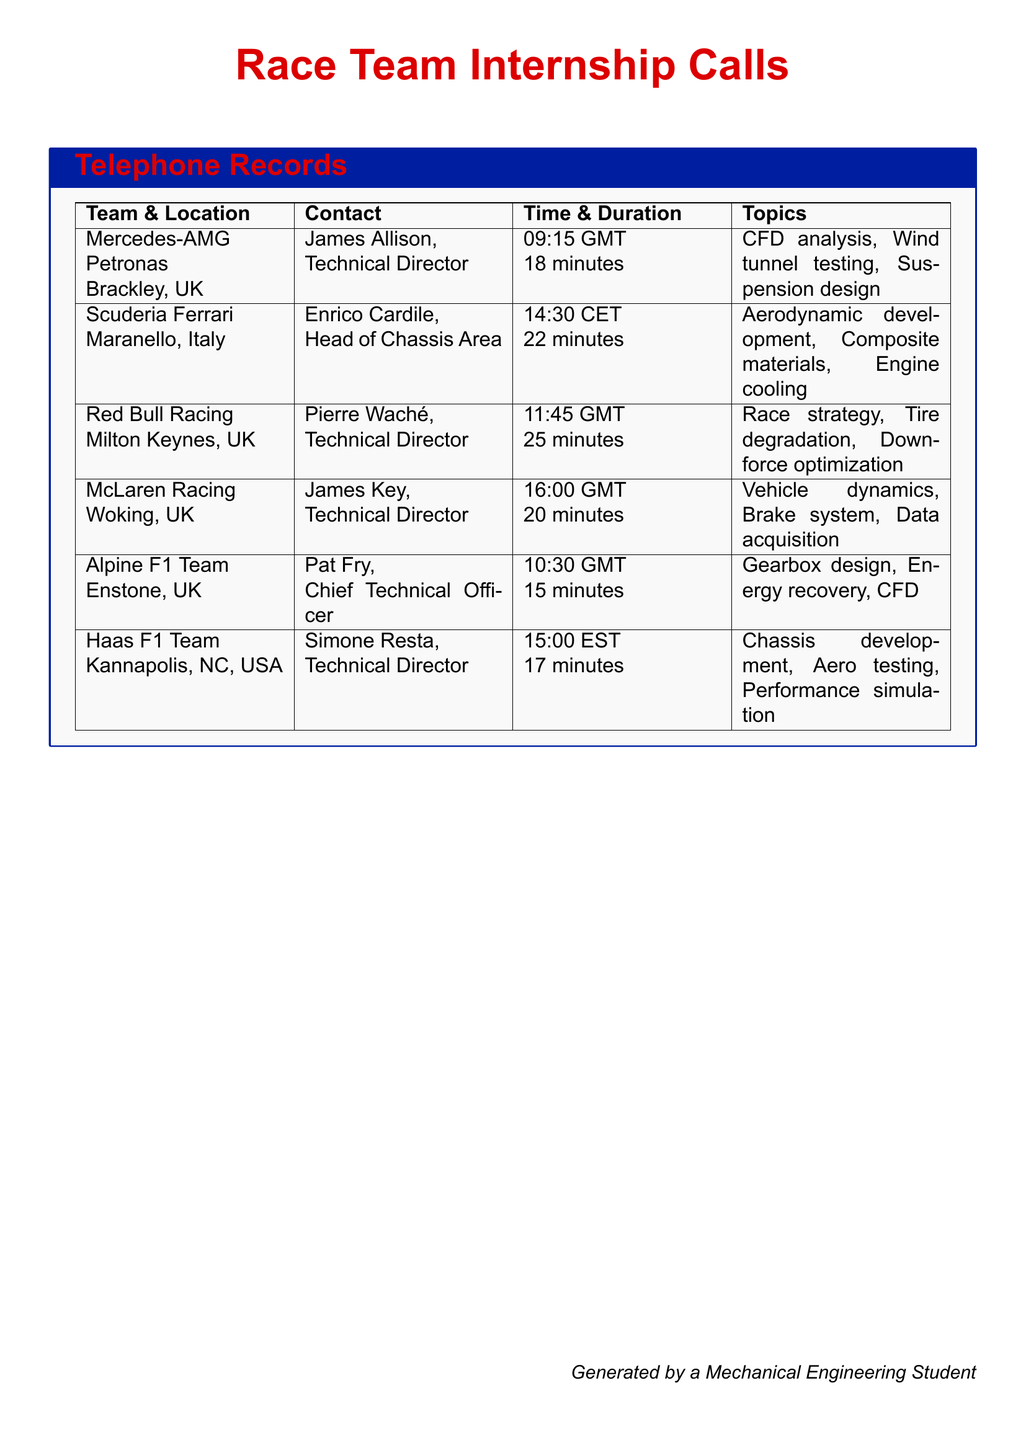What is the name of the Technical Director at Mercedes-AMG Petronas? The Technical Director at Mercedes-AMG Petronas is James Allison.
Answer: James Allison What is the duration of the call with Scuderia Ferrari? The call with Scuderia Ferrari lasted for 22 minutes.
Answer: 22 minutes Which team is located in Milton Keynes, UK? The team located in Milton Keynes, UK is Red Bull Racing.
Answer: Red Bull Racing What topics were discussed during the call with Alpine F1 Team? The topics discussed included gearbox design, energy recovery, and CFD.
Answer: Gearbox design, Energy recovery, CFD How many minutes did the call with Haas F1 Team last? The call with Haas F1 Team lasted for 17 minutes.
Answer: 17 minutes Which team's contact person is Enrico Cardile? Enrico Cardile is the contact person for Scuderia Ferrari.
Answer: Scuderia Ferrari What time zone was used for the call with McLaren Racing? The call with McLaren Racing was in GMT.
Answer: GMT What are the topics discussed during the call with Red Bull Racing? The topics discussed included race strategy, tire degradation, and downforce optimization.
Answer: Race strategy, Tire degradation, Downforce optimization Which team discussed aerodynamic development? The team that discussed aerodynamic development is Scuderia Ferrari.
Answer: Scuderia Ferrari 